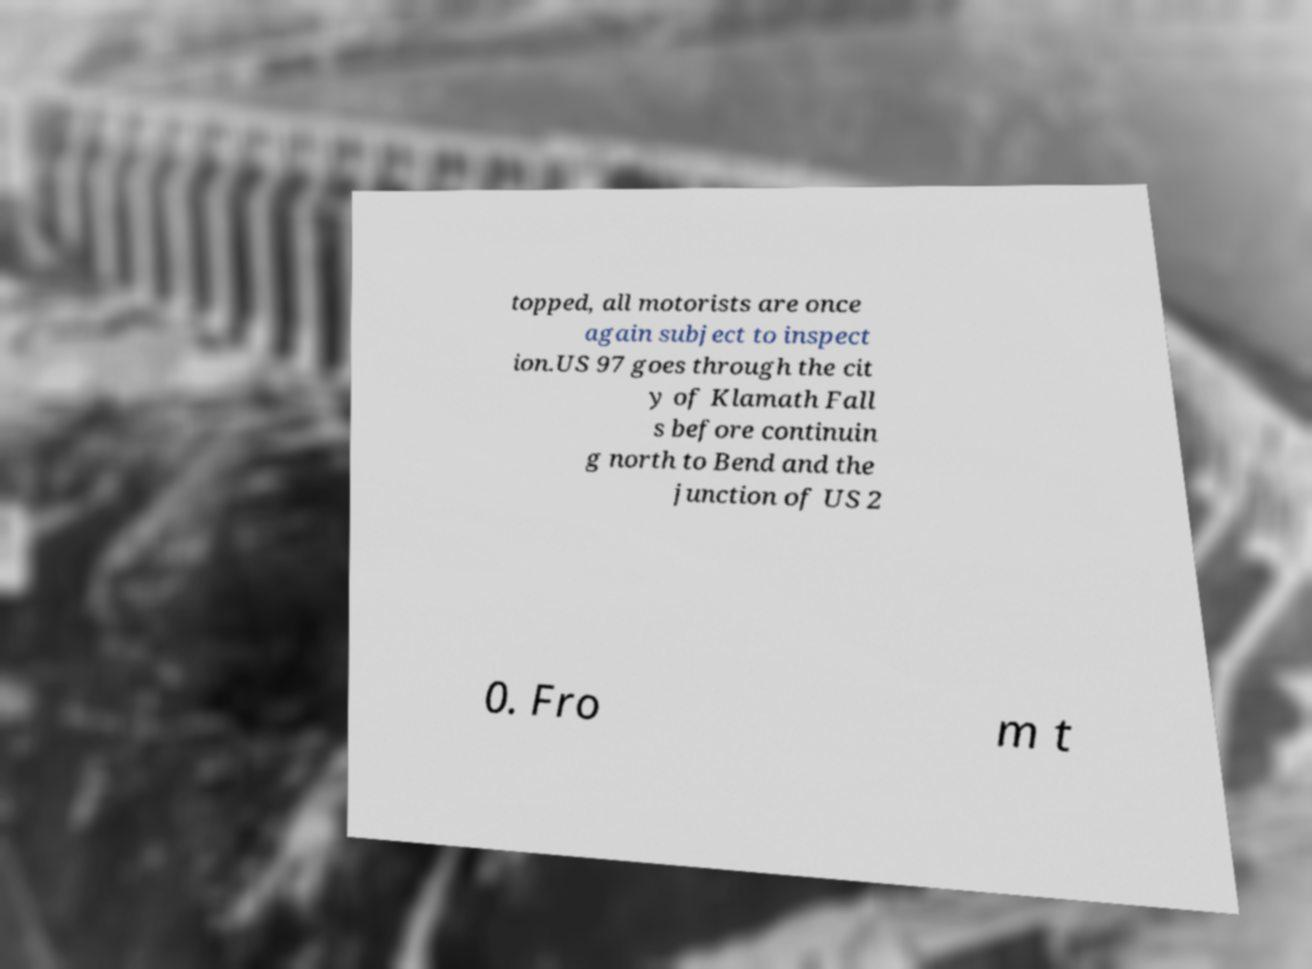Can you accurately transcribe the text from the provided image for me? topped, all motorists are once again subject to inspect ion.US 97 goes through the cit y of Klamath Fall s before continuin g north to Bend and the junction of US 2 0. Fro m t 